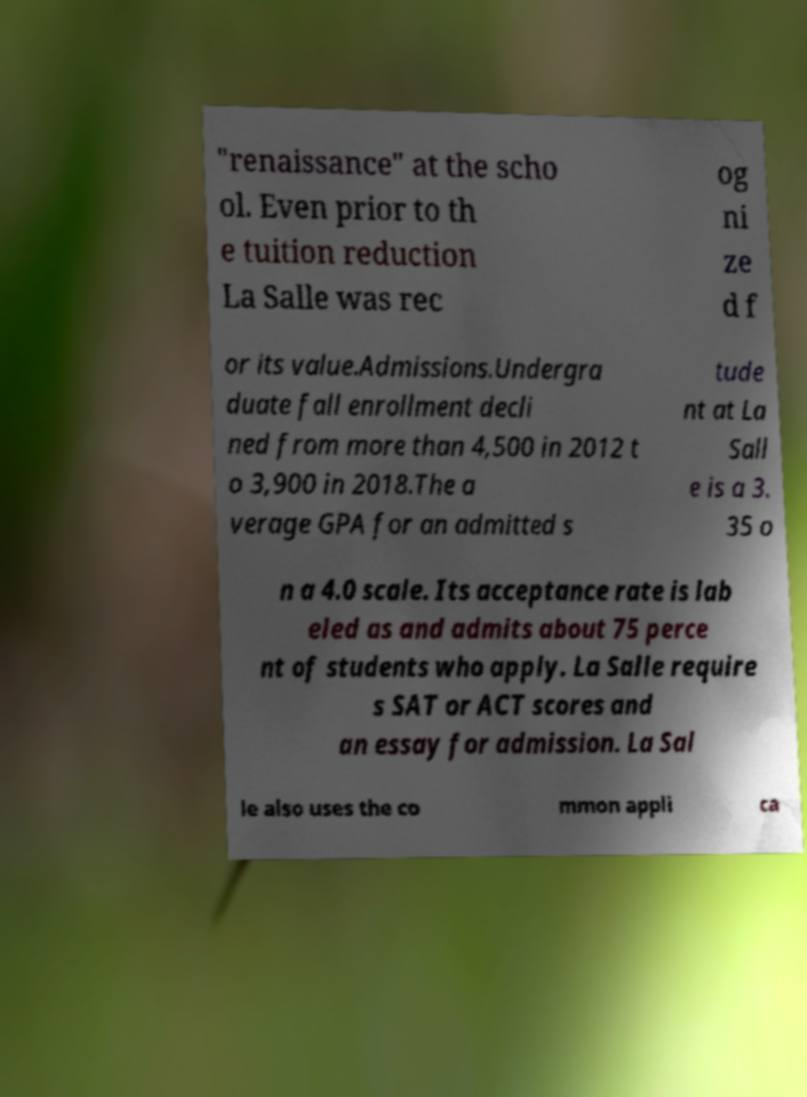Could you assist in decoding the text presented in this image and type it out clearly? "renaissance" at the scho ol. Even prior to th e tuition reduction La Salle was rec og ni ze d f or its value.Admissions.Undergra duate fall enrollment decli ned from more than 4,500 in 2012 t o 3,900 in 2018.The a verage GPA for an admitted s tude nt at La Sall e is a 3. 35 o n a 4.0 scale. Its acceptance rate is lab eled as and admits about 75 perce nt of students who apply. La Salle require s SAT or ACT scores and an essay for admission. La Sal le also uses the co mmon appli ca 